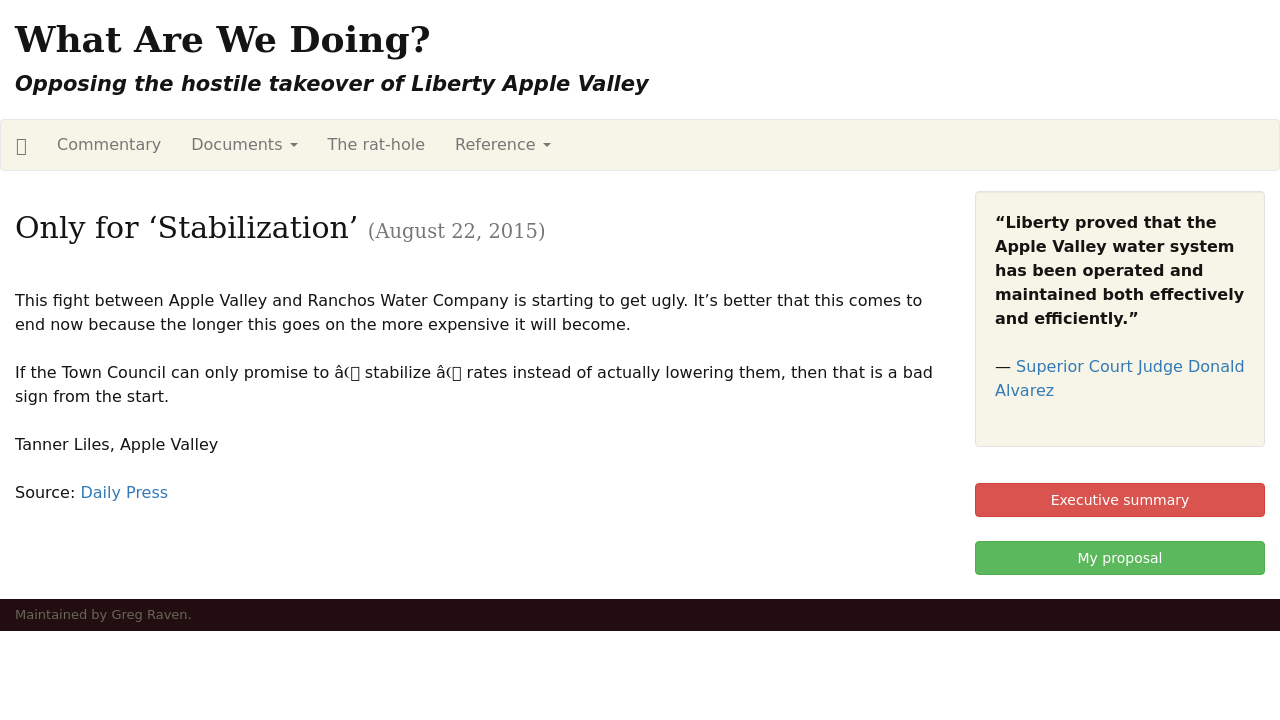Can you describe the significance of the website header displayed in the image? The website header from the image prominently presents the main question 'What Are We Doing?' set against a straightforward and impactful backdrop. This header serves the dual purpose of grabbing the visitor's attention and immediately presenting the central focus of the site, which is opposing the corporate takeover of local water resources in Liberty Apple Valley. The design choice emphasizes urgency and activism, likely aiming to engage visitors and encourage them to explore the issues further through articles, documentation, and organizational information provided on the site. 